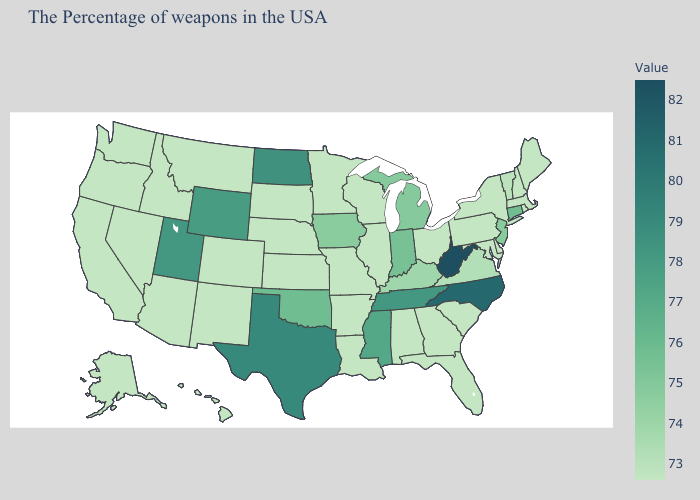Which states have the lowest value in the South?
Write a very short answer. Delaware, Maryland, South Carolina, Florida, Georgia, Alabama, Louisiana, Arkansas. Among the states that border Pennsylvania , which have the highest value?
Concise answer only. West Virginia. Does Utah have the highest value in the West?
Give a very brief answer. Yes. 